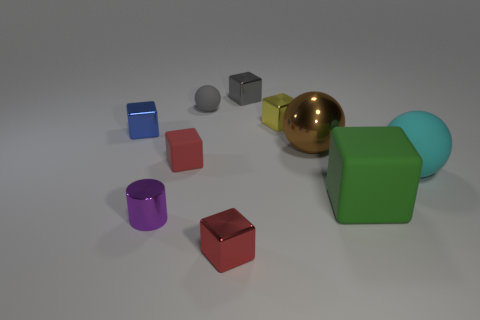What is the size of the purple cylinder?
Provide a short and direct response. Small. What number of things are either small metal blocks or tiny metal blocks that are on the left side of the purple metallic object?
Your response must be concise. 4. What number of other things are the same color as the shiny ball?
Your answer should be very brief. 0. There is a blue shiny block; does it have the same size as the rubber ball left of the yellow shiny object?
Your response must be concise. Yes. Do the rubber ball that is in front of the blue metallic block and the big rubber cube have the same size?
Offer a very short reply. Yes. How many other objects are the same material as the green cube?
Ensure brevity in your answer.  3. Is the number of tiny yellow cubes that are on the right side of the yellow metal block the same as the number of big objects that are right of the brown metal sphere?
Offer a terse response. No. What color is the rubber ball that is in front of the large object to the left of the matte block right of the small matte block?
Offer a very short reply. Cyan. There is a small yellow metallic object that is behind the brown ball; what is its shape?
Ensure brevity in your answer.  Cube. There is a tiny gray thing that is the same material as the big brown thing; what shape is it?
Keep it short and to the point. Cube. 